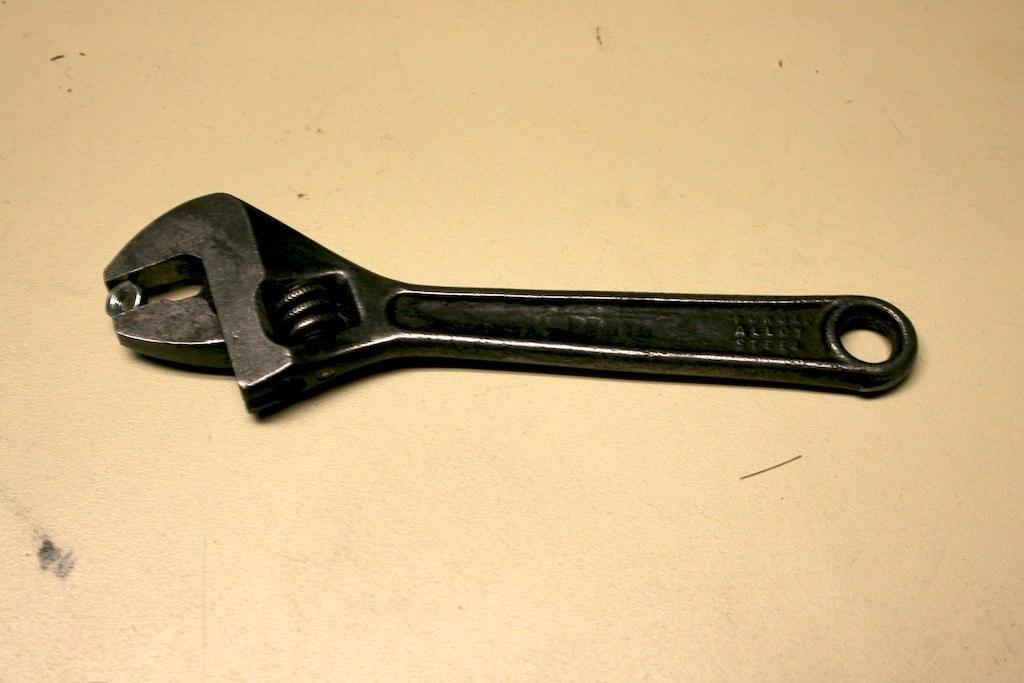What is the main subject in the center of the image? There is a table in the center of the image. Is there anything on the table? Yes, there is an object on the table. What can be said about the color of the object on the table? The object is black in color. What song is being played on the table in the image? There is no song being played on the table in the image; it is an object, not a musical instrument or device. 